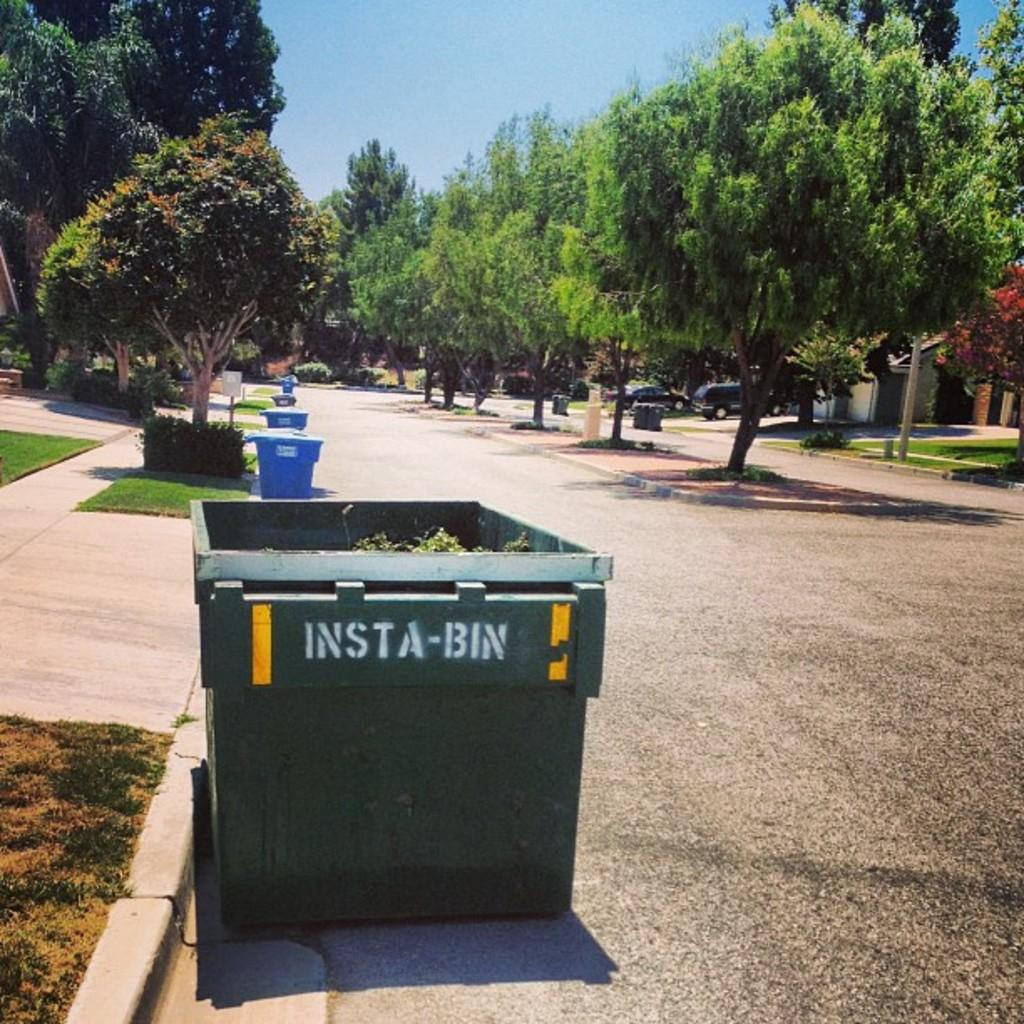Provide a one-sentence caption for the provided image. An insta-bin is on the curb for trash pick up on a tree lined street. 